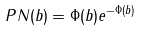<formula> <loc_0><loc_0><loc_500><loc_500>P N ( b ) = \Phi ( b ) e ^ { - \Phi ( b ) }</formula> 